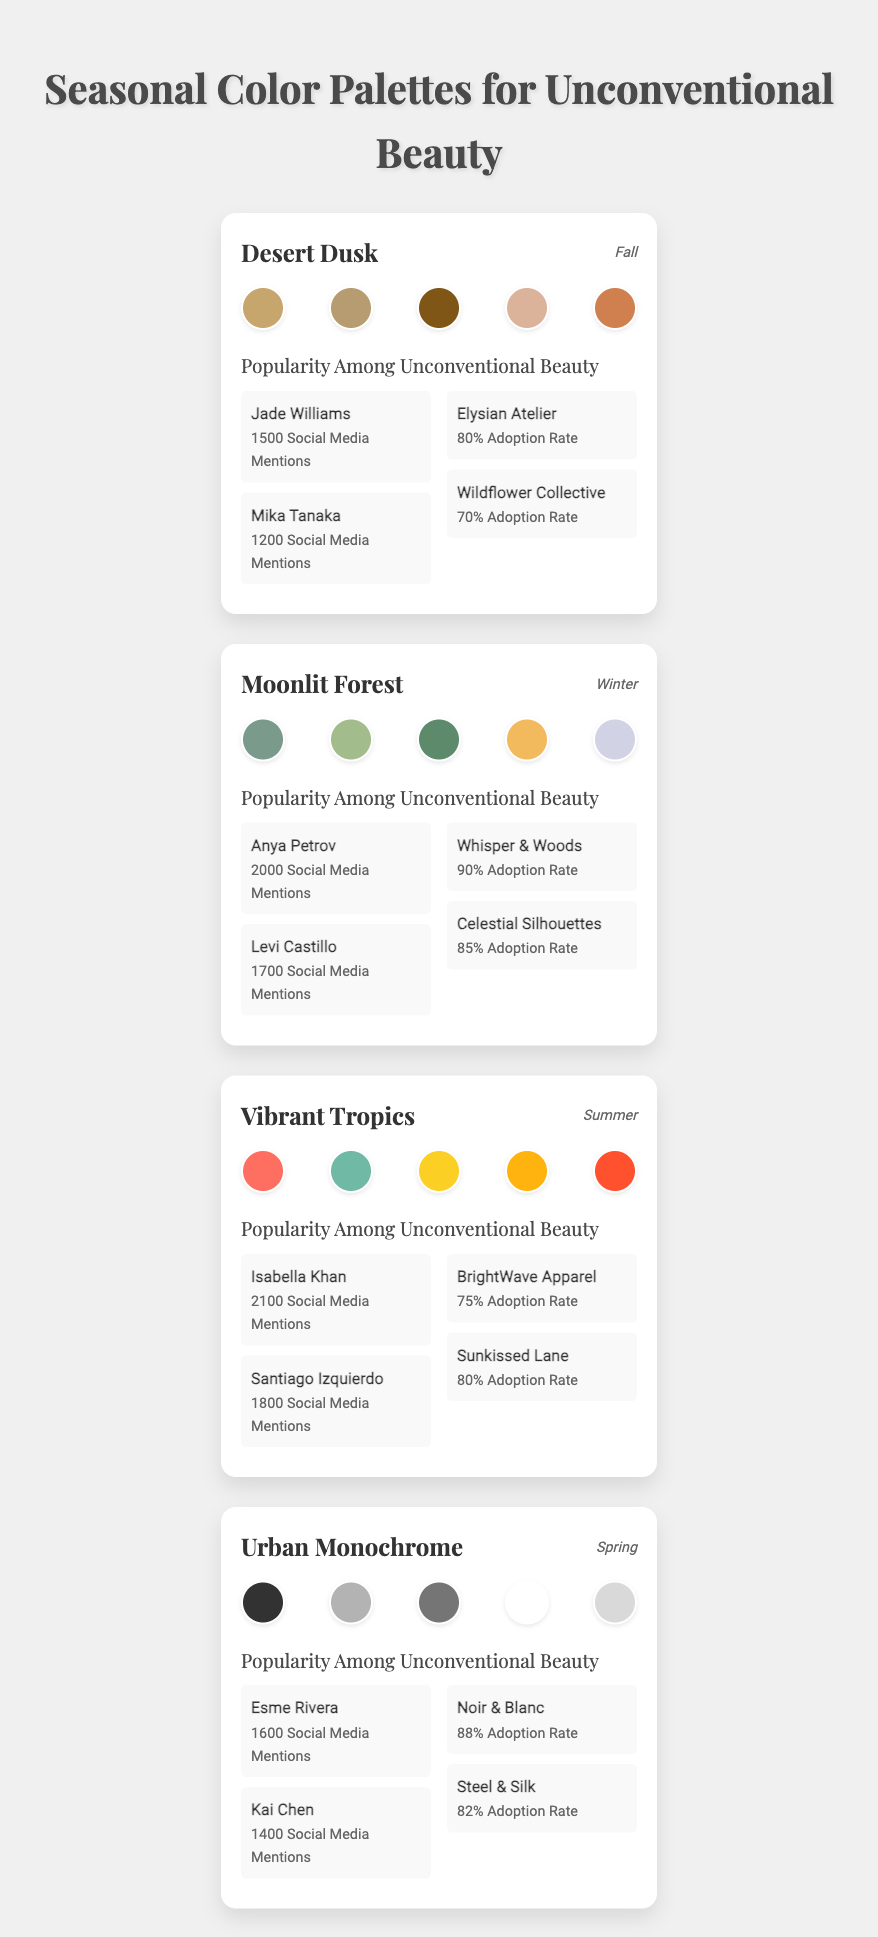What is the color with the highest adoption rate in the Desert Dusk palette? In the Desert Dusk palette, the brands listed are Elysian Atelier with an 80% adoption rate and Wildflower Collective with a 70% adoption rate. The highest adoption rate is 80%.
Answer: 80% Which model has the most social media mentions in the Vibrant Tropics palette? In the Vibrant Tropics palette, Isabella Khan has 2100 social media mentions, which is higher than Santiago Izquierdo's 1800 mentions. Thus, Isabella Khan has the most mentions.
Answer: Isabella Khan How many social media mentions do models in the Moonlit Forest palette collectively have? The models in the Moonlit Forest palette are Anya Petrov (2000 mentions) and Levi Castillo (1700 mentions). Adding these gives a total of 2000 + 1700 = 3700 mentions.
Answer: 3700 Which brand in the Urban Monochrome palette has a higher adoption rate, Noir & Blanc or Steel & Silk? Noir & Blanc has an adoption rate of 88%, while Steel & Silk has an adoption rate of 82%. Since 88% is greater than 82%, Noir & Blanc has the higher adoption rate.
Answer: Noir & Blanc Is the popularity of the Desert Dusk palette among unconventional beauty standards higher than that of the Vibrant Tropics palette? The total social media mentions for the Desert Dusk palette are 1500 (Jade Williams) + 1200 (Mika Tanaka) = 2700, whereas for the Vibrant Tropics palette, it's 2100 (Isabella Khan) + 1800 (Santiago Izquierdo) = 3900. Therefore, 2700 < 3900, so the Desert Dusk palette is less popular.
Answer: No What is the average adoption rate of brands in the Winter color palette? The brands in the Moonlit Forest palette are Whisper & Woods (90% adoption) and Celestial Silhouettes (85% adoption). The average adoption rate can be calculated as (90 + 85) / 2 = 175 / 2 = 87.5%.
Answer: 87.5% Which palette had the least social media mentions among its models? The Desert Dusk palette has models Jade Williams (1500 mentions) and Mika Tanaka (1200 mentions), adding to a total of 2700 mentions. All other palettes have higher totals, so this is the least.
Answer: Desert Dusk Which model participated in the highest number of fashion shows among those listed? Each model's fashion show participation is as follows: Jade Williams - 1, Mika Tanaka - 1, Anya Petrov - 1, Levi Castillo - 1, Isabella Khan - 1, Santiago Izquierdo - 1, Esme Rivera - 1, and Kai Chen - 1. Since all participated in only one show, there's no higher number.
Answer: All models participated in 1 show 